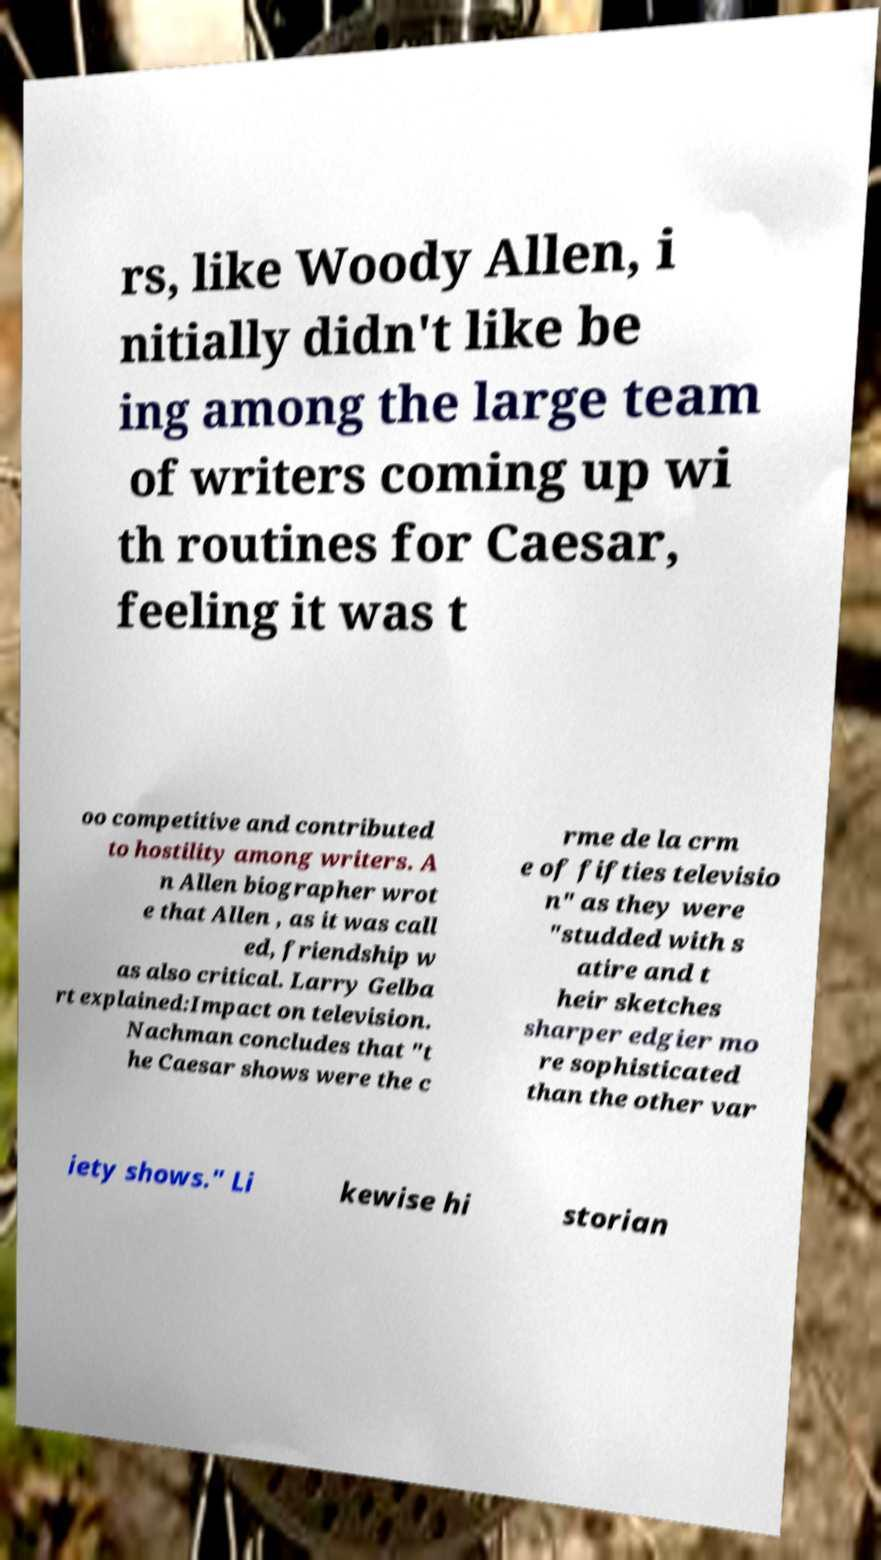Could you extract and type out the text from this image? rs, like Woody Allen, i nitially didn't like be ing among the large team of writers coming up wi th routines for Caesar, feeling it was t oo competitive and contributed to hostility among writers. A n Allen biographer wrot e that Allen , as it was call ed, friendship w as also critical. Larry Gelba rt explained:Impact on television. Nachman concludes that "t he Caesar shows were the c rme de la crm e of fifties televisio n" as they were "studded with s atire and t heir sketches sharper edgier mo re sophisticated than the other var iety shows." Li kewise hi storian 